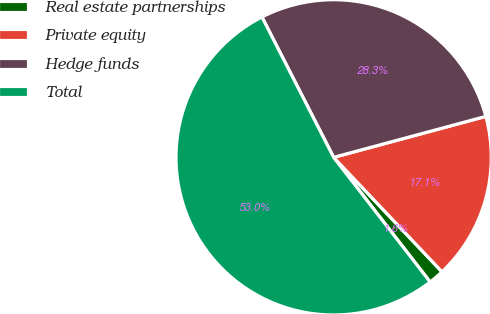Convert chart. <chart><loc_0><loc_0><loc_500><loc_500><pie_chart><fcel>Real estate partnerships<fcel>Private equity<fcel>Hedge funds<fcel>Total<nl><fcel>1.58%<fcel>17.12%<fcel>28.33%<fcel>52.97%<nl></chart> 